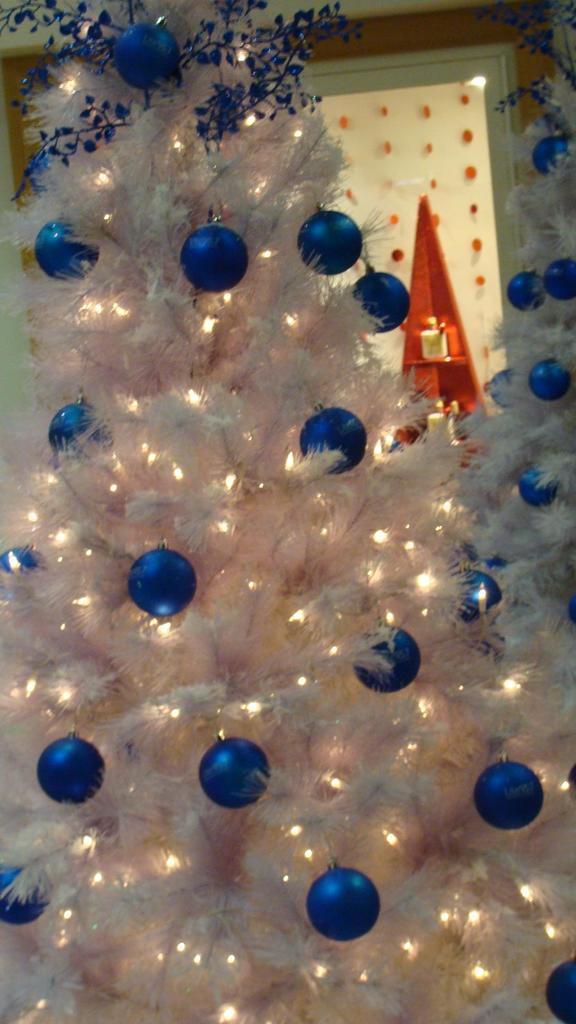Could you give a brief overview of what you see in this image? In this image we can see two Christmas trees which are decorated with some balls and lights. On the backside we can see an object and hangings from a door and a wall. 